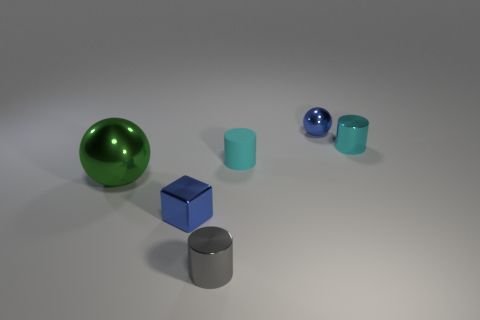Add 1 small shiny things. How many objects exist? 7 Subtract all cubes. How many objects are left? 5 Subtract all tiny yellow spheres. Subtract all cyan rubber cylinders. How many objects are left? 5 Add 1 blue spheres. How many blue spheres are left? 2 Add 5 big cyan rubber things. How many big cyan rubber things exist? 5 Subtract 0 red cubes. How many objects are left? 6 